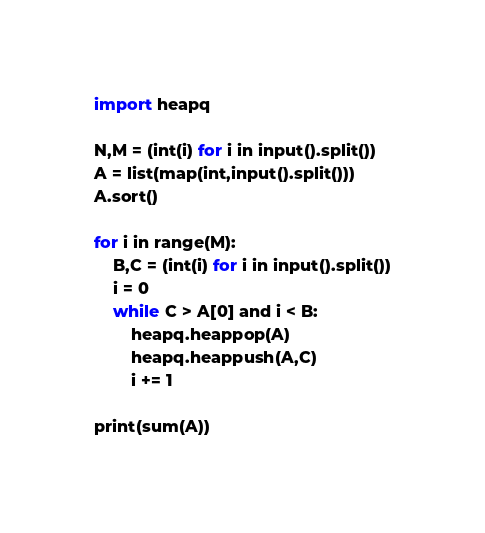Convert code to text. <code><loc_0><loc_0><loc_500><loc_500><_Python_>import heapq

N,M = (int(i) for i in input().split())
A = list(map(int,input().split()))
A.sort()

for i in range(M):
    B,C = (int(i) for i in input().split())
    i = 0
    while C > A[0] and i < B:
        heapq.heappop(A)
        heapq.heappush(A,C)
        i += 1

print(sum(A))
</code> 